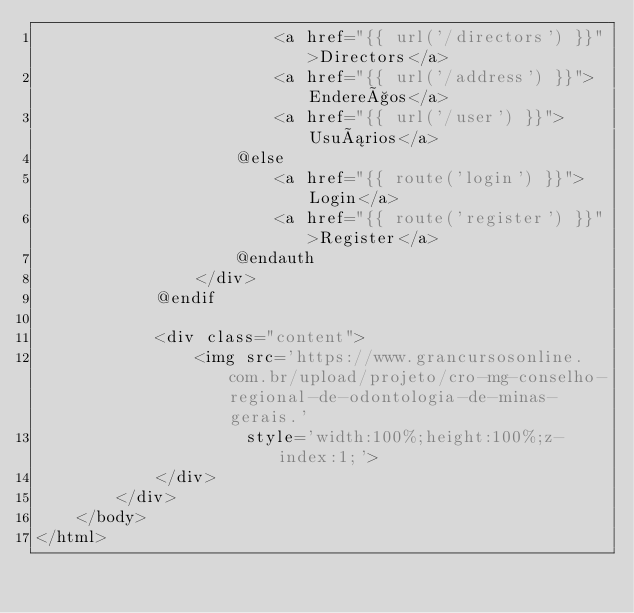Convert code to text. <code><loc_0><loc_0><loc_500><loc_500><_PHP_>                        <a href="{{ url('/directors') }}">Directors</a>
                        <a href="{{ url('/address') }}">Endereços</a>
                        <a href="{{ url('/user') }}">Usuários</a>
                    @else
                        <a href="{{ route('login') }}">Login</a>
                        <a href="{{ route('register') }}">Register</a>
                    @endauth
                </div>
            @endif

            <div class="content">
                <img src='https://www.grancursosonline.com.br/upload/projeto/cro-mg-conselho-regional-de-odontologia-de-minas-gerais.'
                     style='width:100%;height:100%;z-index:1;'>
            </div>
        </div>
    </body>
</html>
</code> 